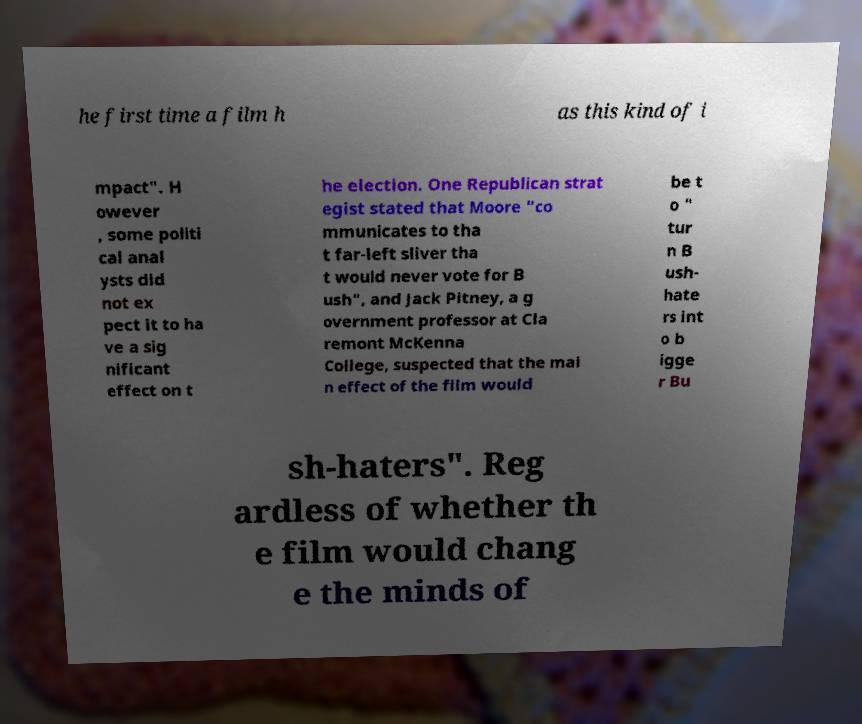Could you extract and type out the text from this image? he first time a film h as this kind of i mpact". H owever , some politi cal anal ysts did not ex pect it to ha ve a sig nificant effect on t he election. One Republican strat egist stated that Moore "co mmunicates to tha t far-left sliver tha t would never vote for B ush", and Jack Pitney, a g overnment professor at Cla remont McKenna College, suspected that the mai n effect of the film would be t o " tur n B ush- hate rs int o b igge r Bu sh-haters". Reg ardless of whether th e film would chang e the minds of 